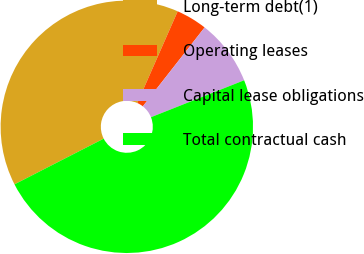Convert chart to OTSL. <chart><loc_0><loc_0><loc_500><loc_500><pie_chart><fcel>Long-term debt(1)<fcel>Operating leases<fcel>Capital lease obligations<fcel>Total contractual cash<nl><fcel>39.14%<fcel>3.97%<fcel>8.42%<fcel>48.48%<nl></chart> 